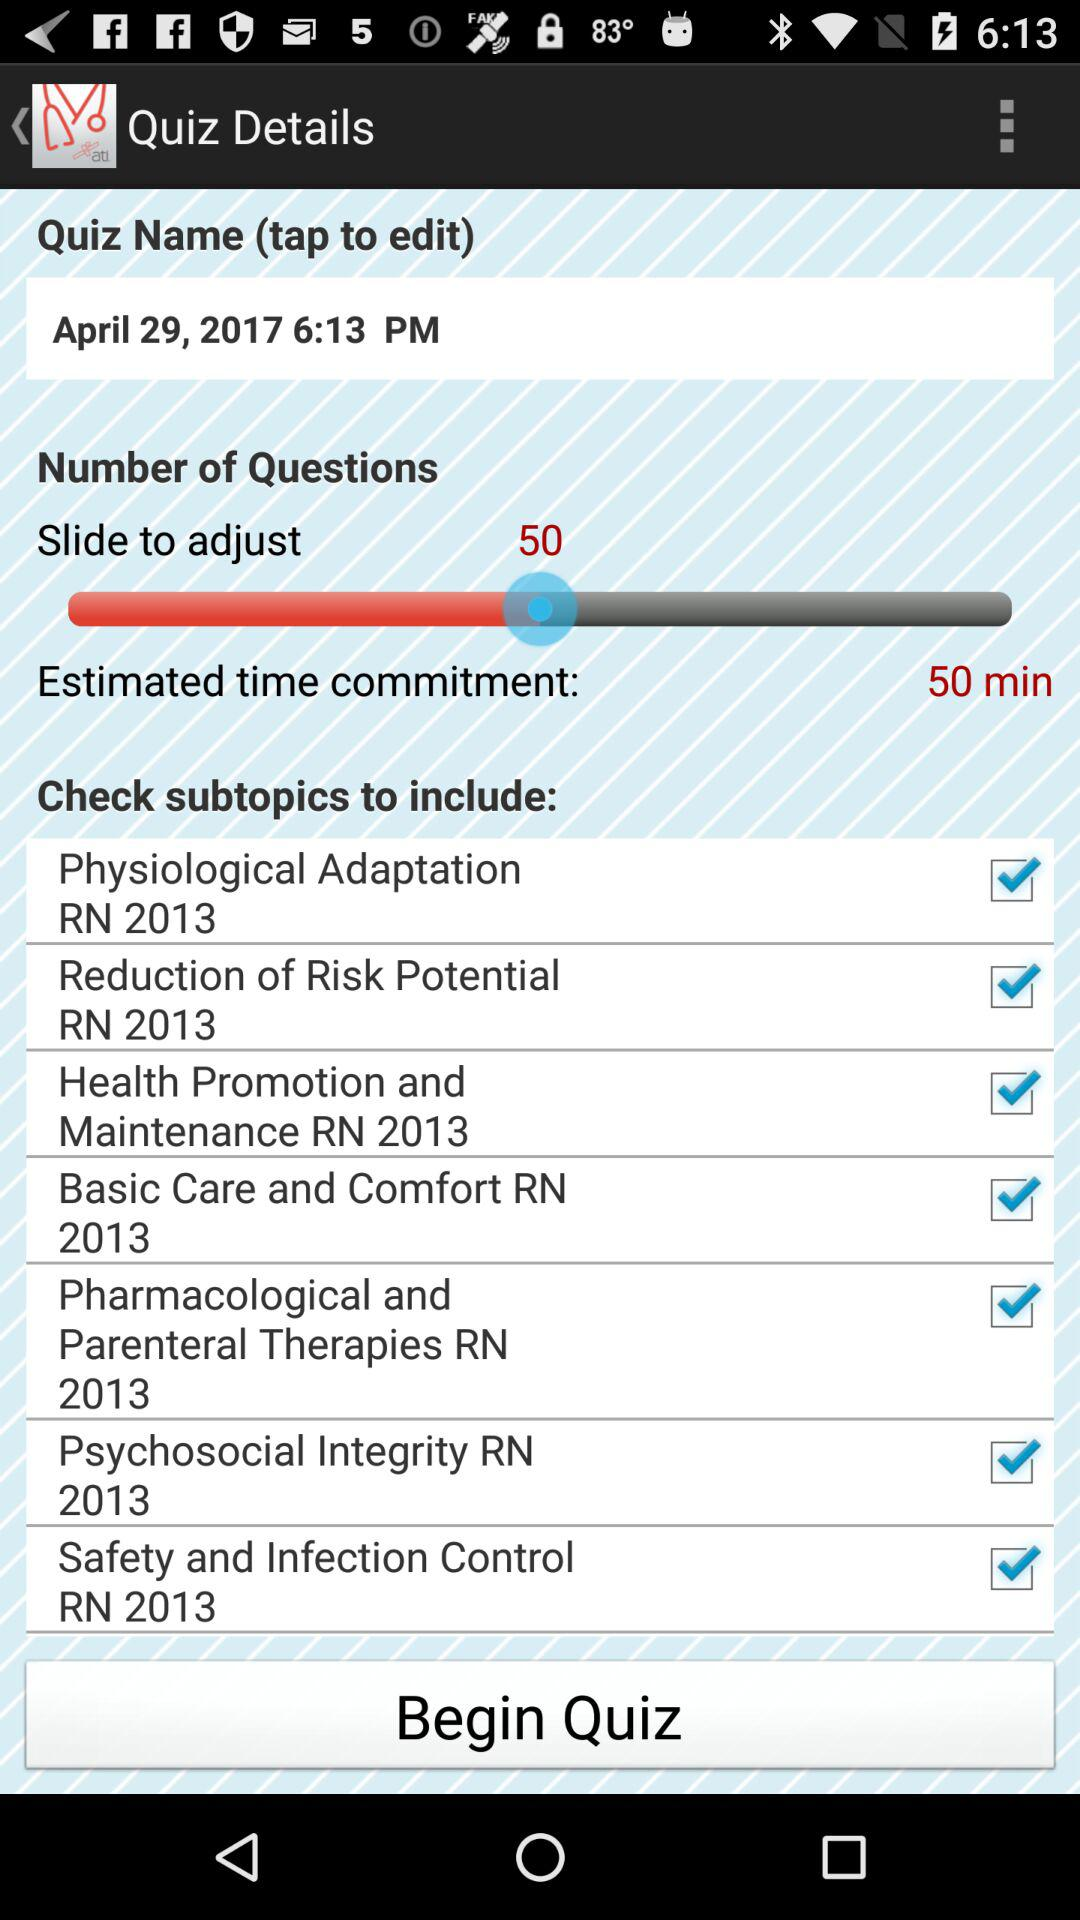What is the set number of questions? The set number of questions is 50. 